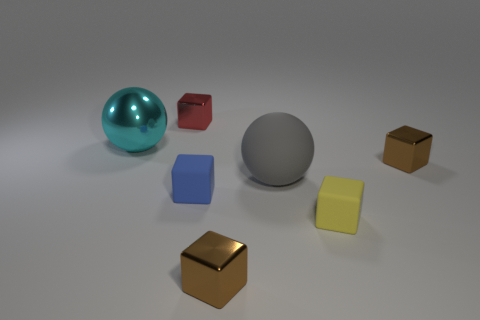Subtract all cyan balls. How many balls are left? 1 Subtract all red shiny cubes. How many cubes are left? 4 Subtract all spheres. How many objects are left? 5 Subtract 4 blocks. How many blocks are left? 1 Add 3 small red shiny blocks. How many objects exist? 10 Subtract all blue blocks. How many gray spheres are left? 1 Subtract 0 gray cubes. How many objects are left? 7 Subtract all gray blocks. Subtract all green cylinders. How many blocks are left? 5 Subtract all yellow rubber cubes. Subtract all metallic balls. How many objects are left? 5 Add 2 gray rubber objects. How many gray rubber objects are left? 3 